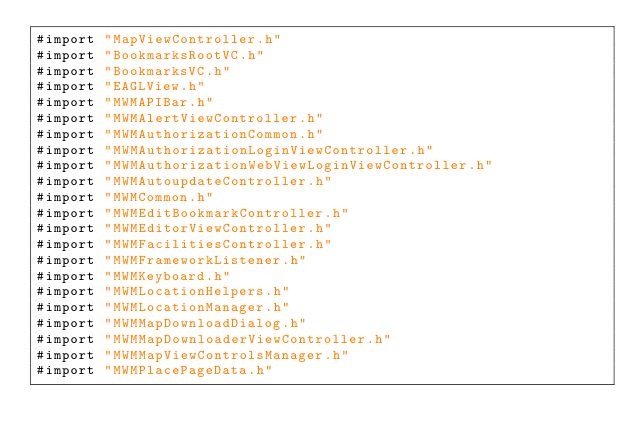<code> <loc_0><loc_0><loc_500><loc_500><_ObjectiveC_>#import "MapViewController.h"
#import "BookmarksRootVC.h"
#import "BookmarksVC.h"
#import "EAGLView.h"
#import "MWMAPIBar.h"
#import "MWMAlertViewController.h"
#import "MWMAuthorizationCommon.h"
#import "MWMAuthorizationLoginViewController.h"
#import "MWMAuthorizationWebViewLoginViewController.h"
#import "MWMAutoupdateController.h"
#import "MWMCommon.h"
#import "MWMEditBookmarkController.h"
#import "MWMEditorViewController.h"
#import "MWMFacilitiesController.h"
#import "MWMFrameworkListener.h"
#import "MWMKeyboard.h"
#import "MWMLocationHelpers.h"
#import "MWMLocationManager.h"
#import "MWMMapDownloadDialog.h"
#import "MWMMapDownloaderViewController.h"
#import "MWMMapViewControlsManager.h"
#import "MWMPlacePageData.h"</code> 